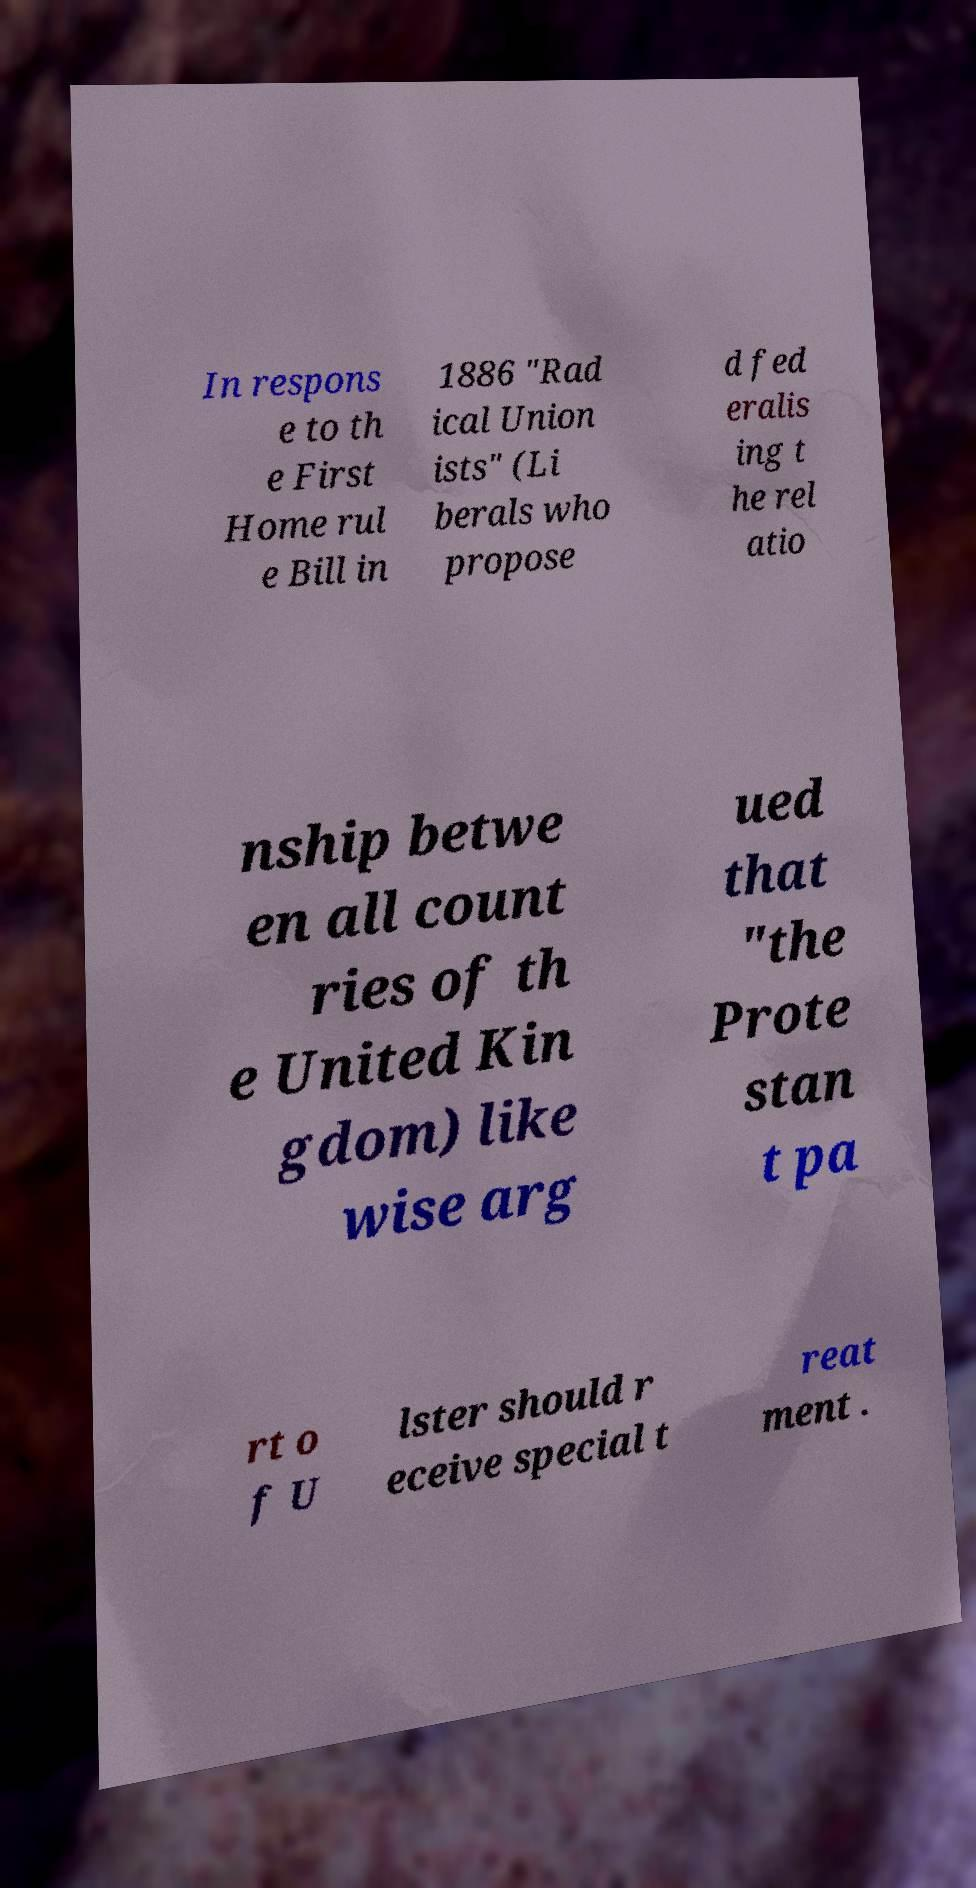I need the written content from this picture converted into text. Can you do that? In respons e to th e First Home rul e Bill in 1886 "Rad ical Union ists" (Li berals who propose d fed eralis ing t he rel atio nship betwe en all count ries of th e United Kin gdom) like wise arg ued that "the Prote stan t pa rt o f U lster should r eceive special t reat ment . 